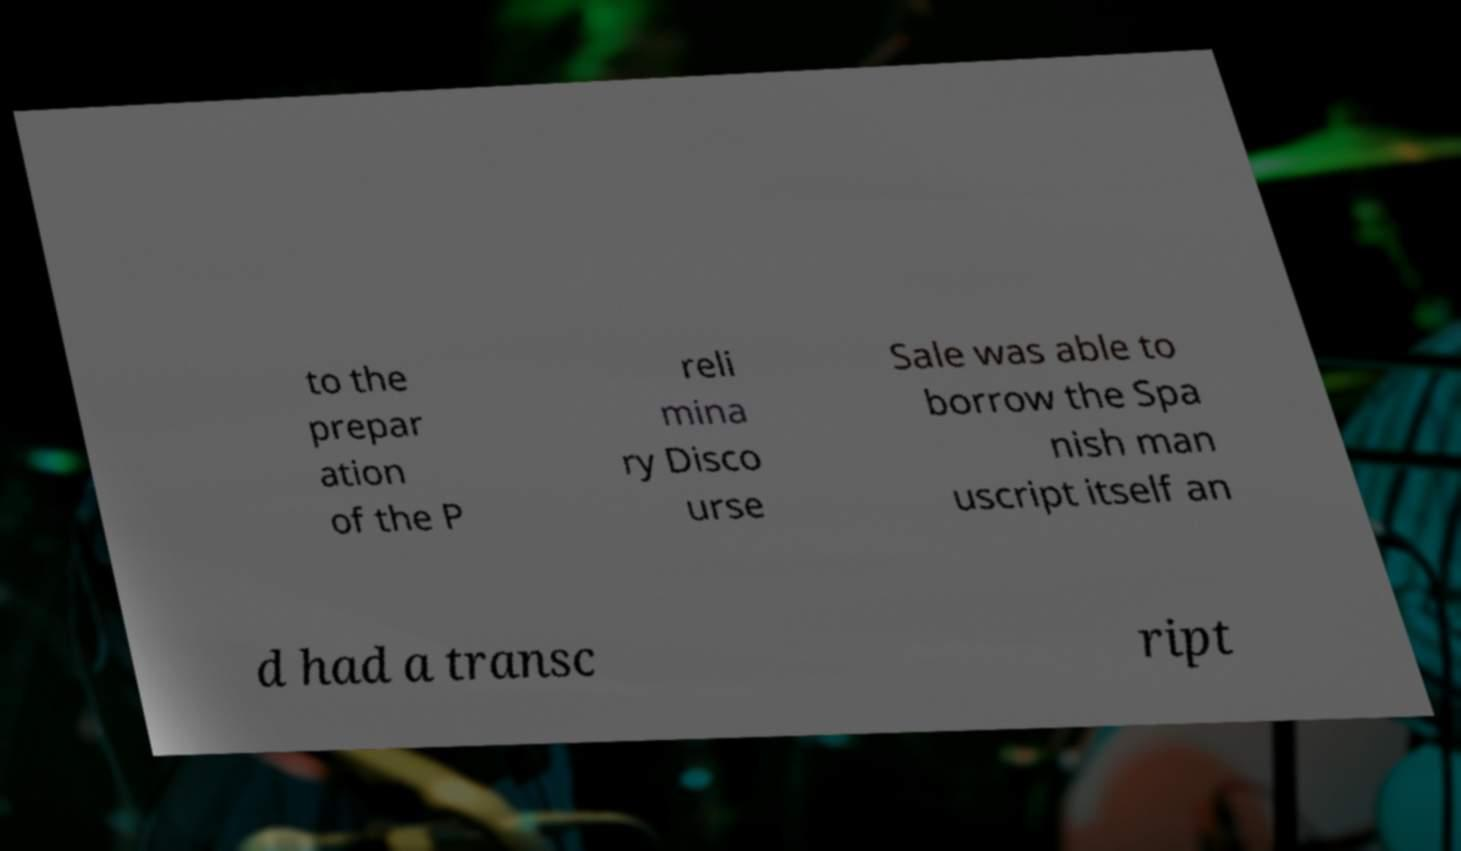Can you accurately transcribe the text from the provided image for me? to the prepar ation of the P reli mina ry Disco urse Sale was able to borrow the Spa nish man uscript itself an d had a transc ript 